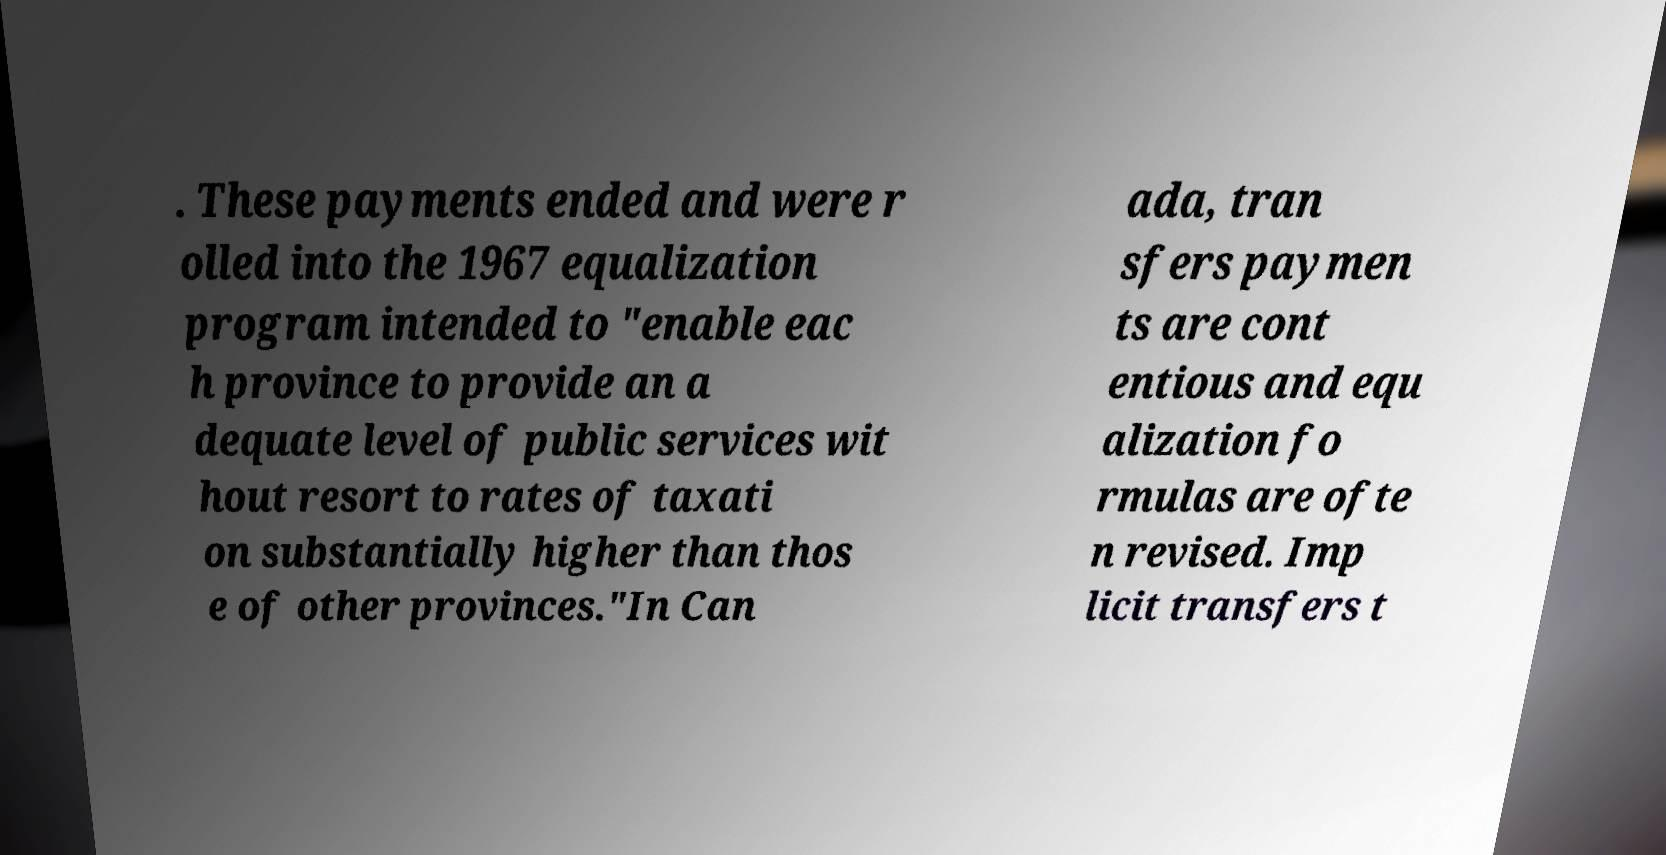What messages or text are displayed in this image? I need them in a readable, typed format. . These payments ended and were r olled into the 1967 equalization program intended to "enable eac h province to provide an a dequate level of public services wit hout resort to rates of taxati on substantially higher than thos e of other provinces."In Can ada, tran sfers paymen ts are cont entious and equ alization fo rmulas are ofte n revised. Imp licit transfers t 